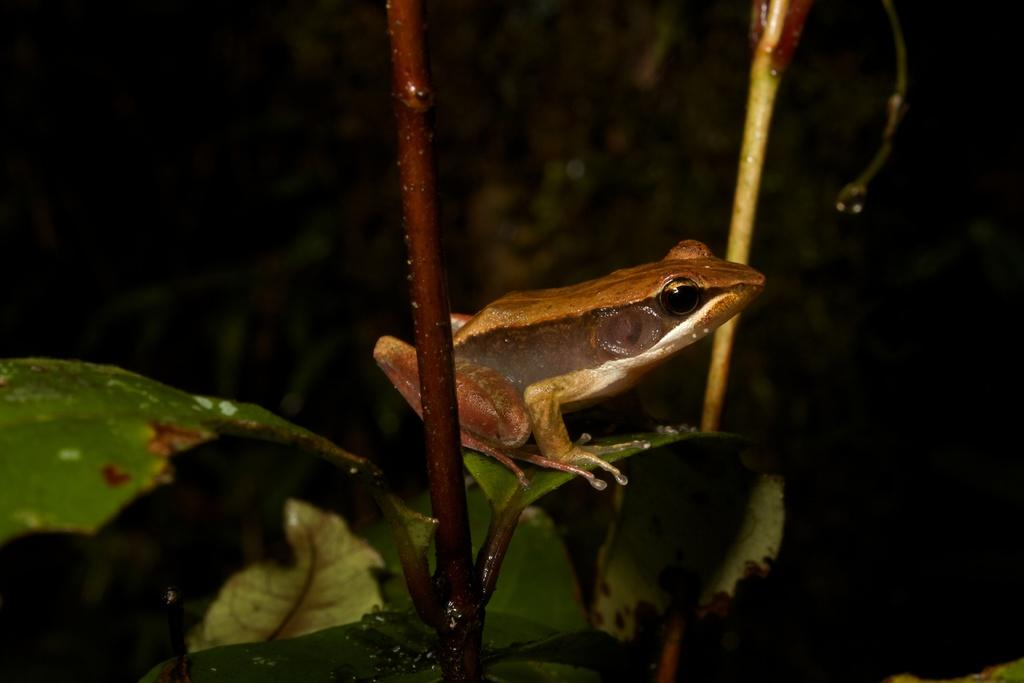What is the main subject of the image? There is a frog on a green leaf. What type of vegetation is present in the image? There are leaves visible in the image. What else can be seen in the image besides the frog and leaves? There are branches visible in the image. What is the color of the background in the image? The background of the image is dark. What type of paint is being used by the frog in the image? There is no paint or painting activity depicted in the image; it features a frog on a green leaf. How many coils can be seen in the image? There are no coils present in the image. 